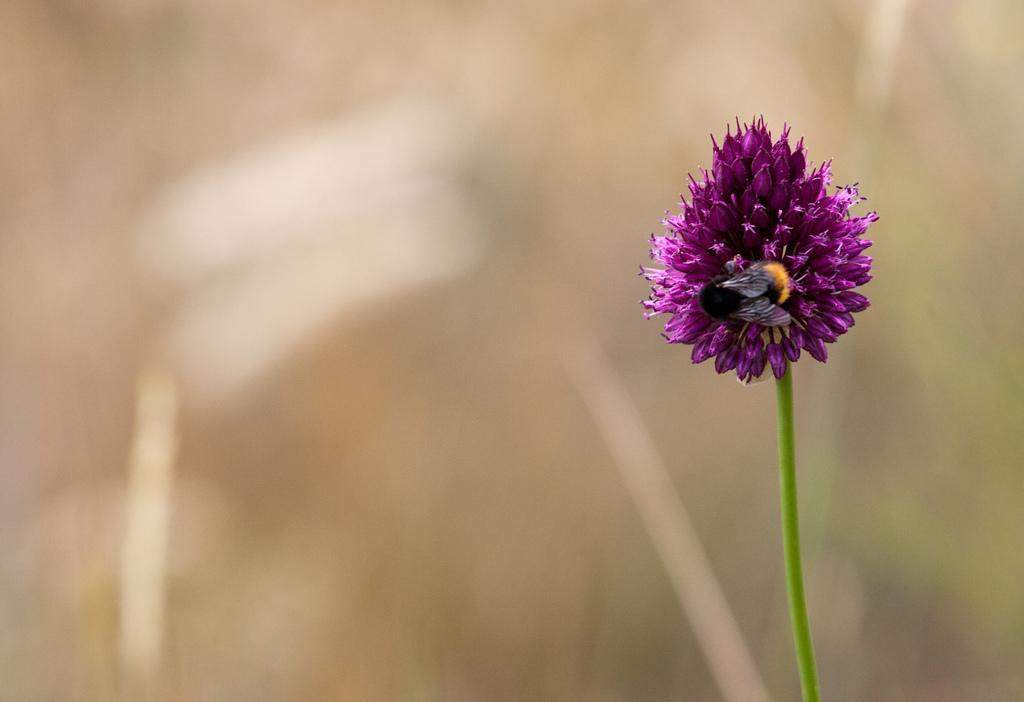Could you give a brief overview of what you see in this image? In this picture I can see a flower with a stem, there is an insect on the flower, and there is blur background. 